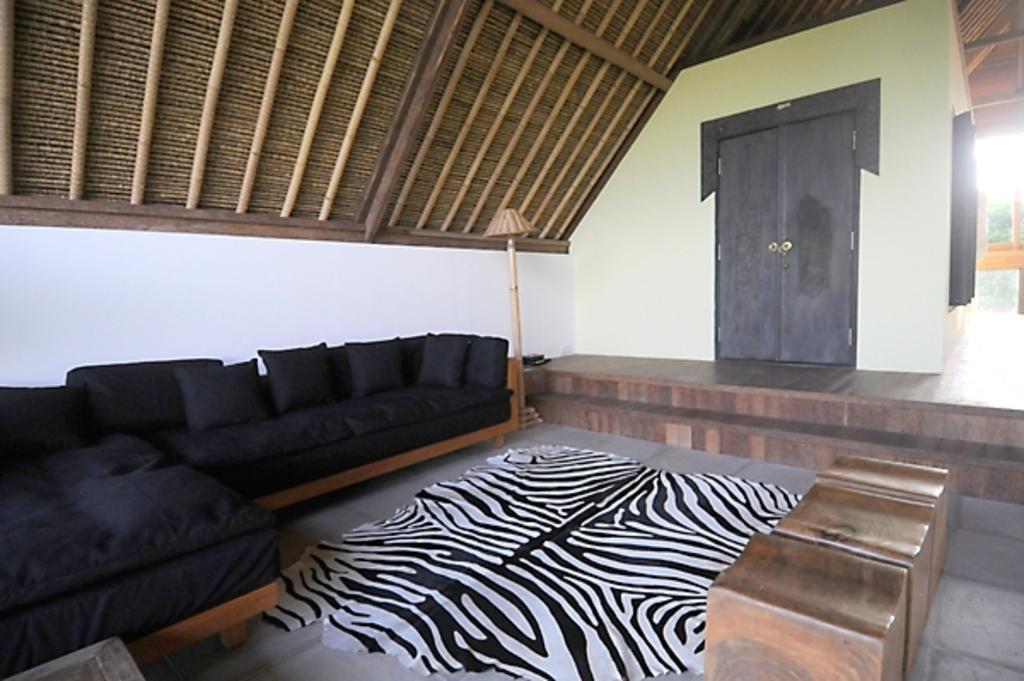Please provide a concise description of this image. This is a picture of the inside of the house. On the left side there is one couch and on that couch there are some pillows and on the top there is one roof and in the middle there is one door and beside the door there is a wall and in the middle there is one lamp and on the floor there is one carpet and on the top of the right corner there is sky. 